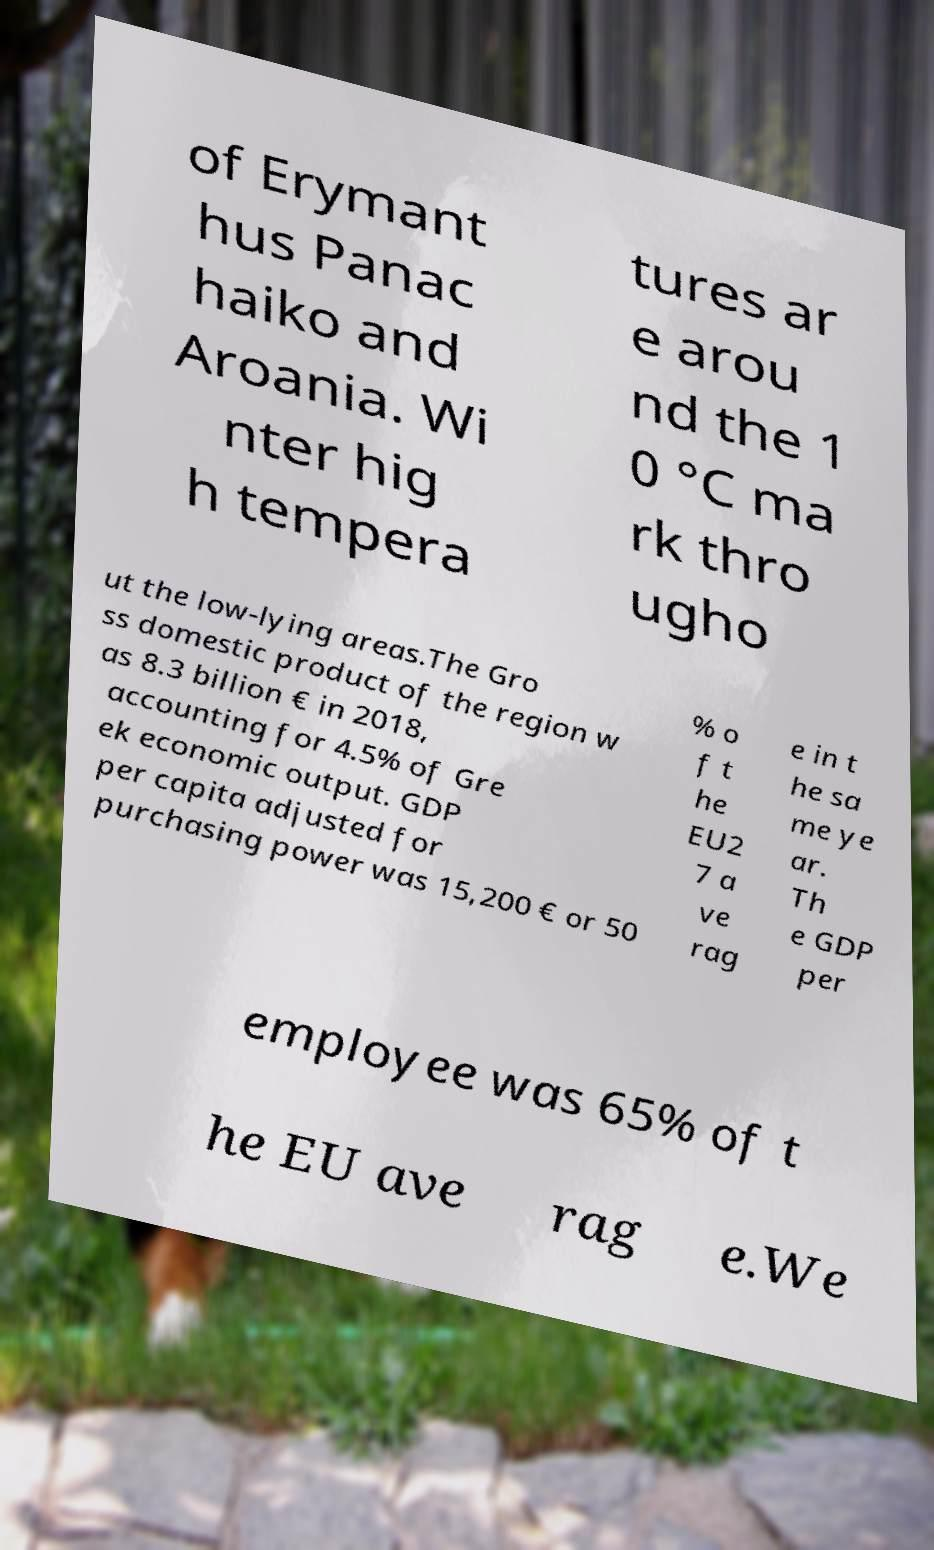What messages or text are displayed in this image? I need them in a readable, typed format. of Erymant hus Panac haiko and Aroania. Wi nter hig h tempera tures ar e arou nd the 1 0 °C ma rk thro ugho ut the low-lying areas.The Gro ss domestic product of the region w as 8.3 billion € in 2018, accounting for 4.5% of Gre ek economic output. GDP per capita adjusted for purchasing power was 15,200 € or 50 % o f t he EU2 7 a ve rag e in t he sa me ye ar. Th e GDP per employee was 65% of t he EU ave rag e.We 